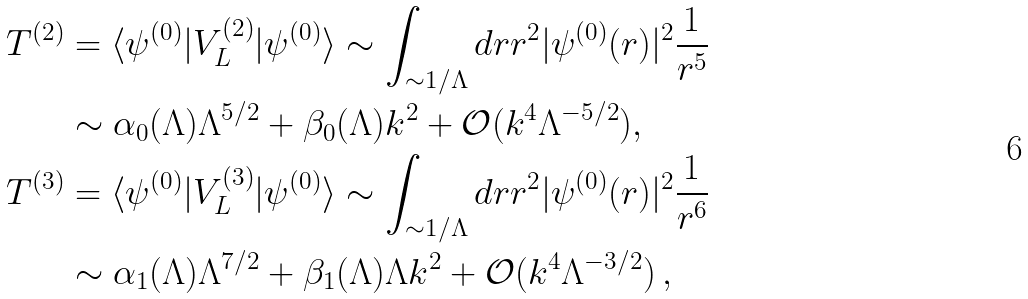Convert formula to latex. <formula><loc_0><loc_0><loc_500><loc_500>T ^ { ( 2 ) } & = \langle \psi ^ { ( 0 ) } | V _ { L } ^ { ( 2 ) } | \psi ^ { ( 0 ) } \rangle \sim \int _ { \sim 1 / \Lambda } d r r ^ { 2 } | \psi ^ { ( 0 ) } ( r ) | ^ { 2 } \frac { 1 } { r ^ { 5 } } \\ & \sim \alpha _ { 0 } ( \Lambda ) \Lambda ^ { 5 / 2 } + \beta _ { 0 } ( \Lambda ) k ^ { 2 } + \mathcal { O } ( k ^ { 4 } \Lambda ^ { - 5 / 2 } ) , \\ T ^ { ( 3 ) } & = \langle \psi ^ { ( 0 ) } | V _ { L } ^ { ( 3 ) } | \psi ^ { ( 0 ) } \rangle \sim \int _ { \sim 1 / \Lambda } d r r ^ { 2 } | \psi ^ { ( 0 ) } ( r ) | ^ { 2 } \frac { 1 } { r ^ { 6 } } \\ & \sim \alpha _ { 1 } ( \Lambda ) \Lambda ^ { 7 / 2 } + \beta _ { 1 } ( \Lambda ) \Lambda k ^ { 2 } + \mathcal { O } ( k ^ { 4 } \Lambda ^ { - 3 / 2 } ) \, ,</formula> 